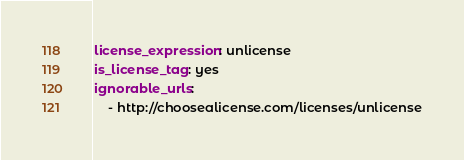<code> <loc_0><loc_0><loc_500><loc_500><_YAML_>license_expression: unlicense
is_license_tag: yes
ignorable_urls:
    - http://choosealicense.com/licenses/unlicense
</code> 